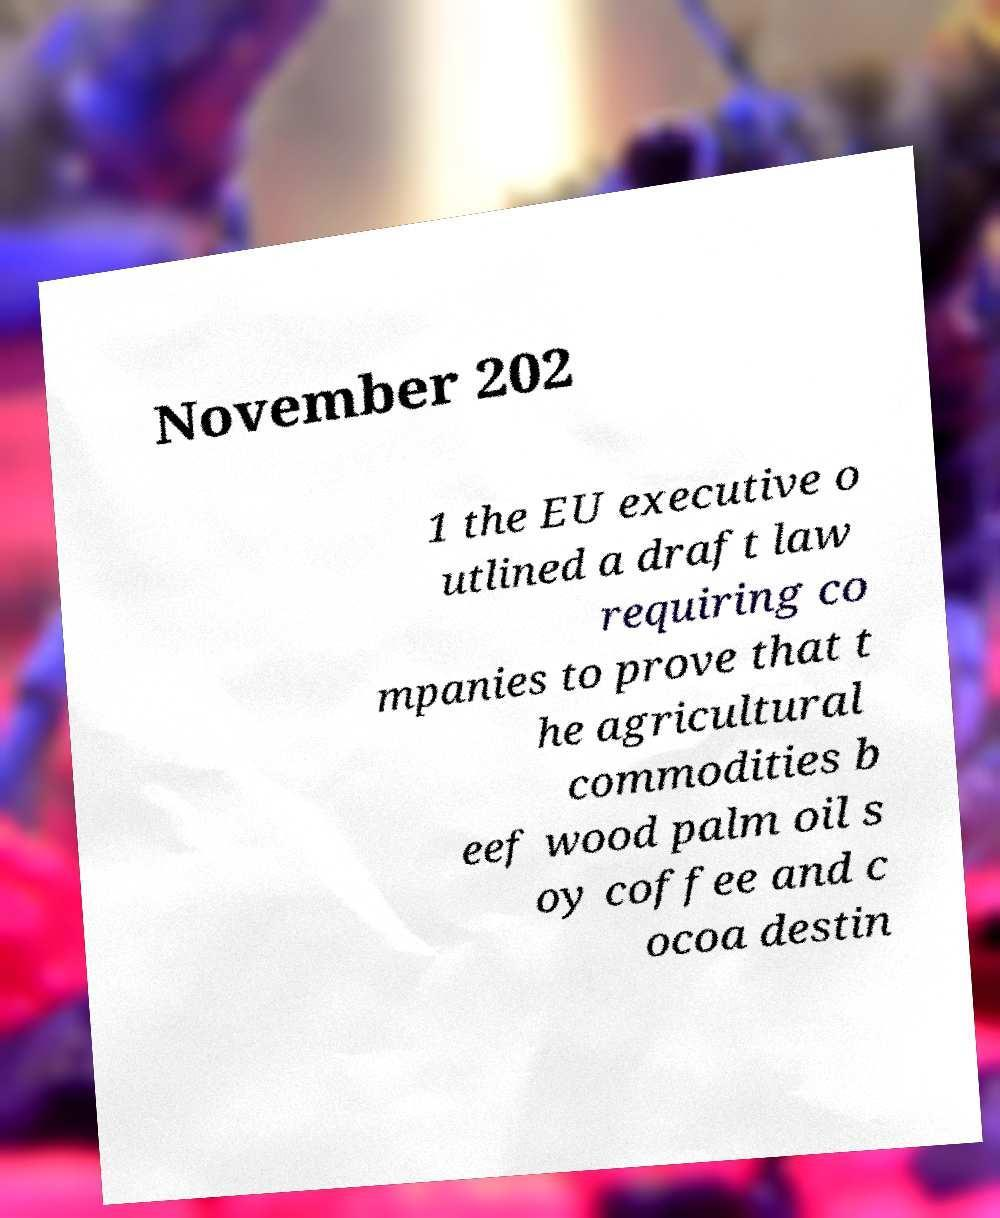For documentation purposes, I need the text within this image transcribed. Could you provide that? November 202 1 the EU executive o utlined a draft law requiring co mpanies to prove that t he agricultural commodities b eef wood palm oil s oy coffee and c ocoa destin 